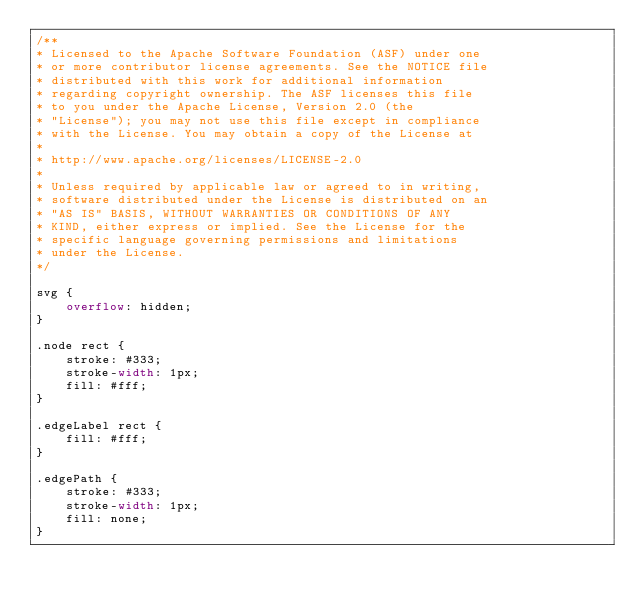<code> <loc_0><loc_0><loc_500><loc_500><_CSS_>/**
* Licensed to the Apache Software Foundation (ASF) under one
* or more contributor license agreements. See the NOTICE file
* distributed with this work for additional information
* regarding copyright ownership. The ASF licenses this file
* to you under the Apache License, Version 2.0 (the
* "License"); you may not use this file except in compliance
* with the License. You may obtain a copy of the License at
*
* http://www.apache.org/licenses/LICENSE-2.0
*
* Unless required by applicable law or agreed to in writing,
* software distributed under the License is distributed on an
* "AS IS" BASIS, WITHOUT WARRANTIES OR CONDITIONS OF ANY
* KIND, either express or implied. See the License for the
* specific language governing permissions and limitations
* under the License.
*/

svg {
    overflow: hidden;
}

.node rect {
    stroke: #333;
    stroke-width: 1px;
    fill: #fff;
}

.edgeLabel rect {
    fill: #fff;
}

.edgePath {
    stroke: #333;
    stroke-width: 1px;
    fill: none;
}
</code> 